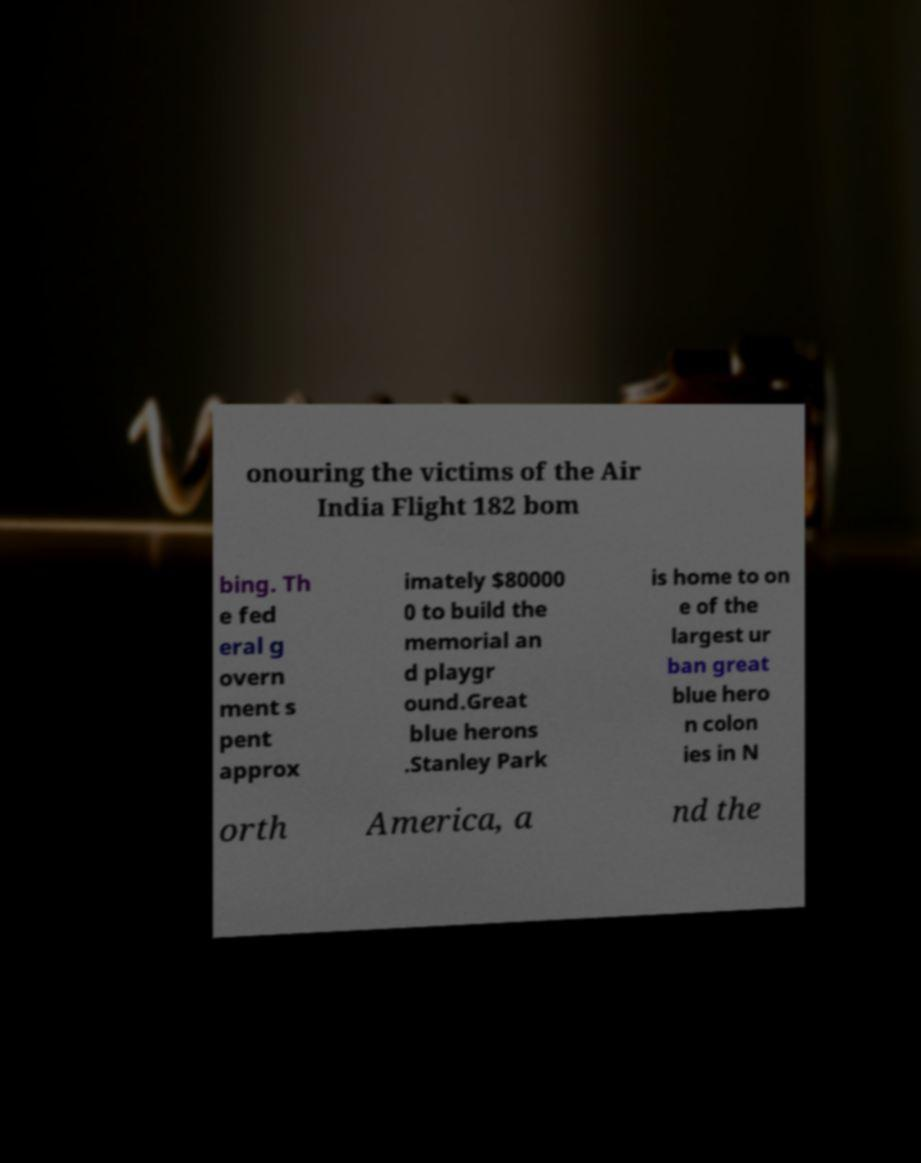I need the written content from this picture converted into text. Can you do that? onouring the victims of the Air India Flight 182 bom bing. Th e fed eral g overn ment s pent approx imately $80000 0 to build the memorial an d playgr ound.Great blue herons .Stanley Park is home to on e of the largest ur ban great blue hero n colon ies in N orth America, a nd the 